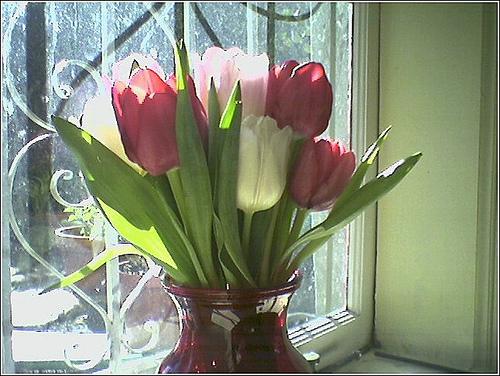What types of flowers are these?
Be succinct. Tulips. Are these tulips real?
Write a very short answer. Yes. What is in the vase?
Be succinct. Tulips. 